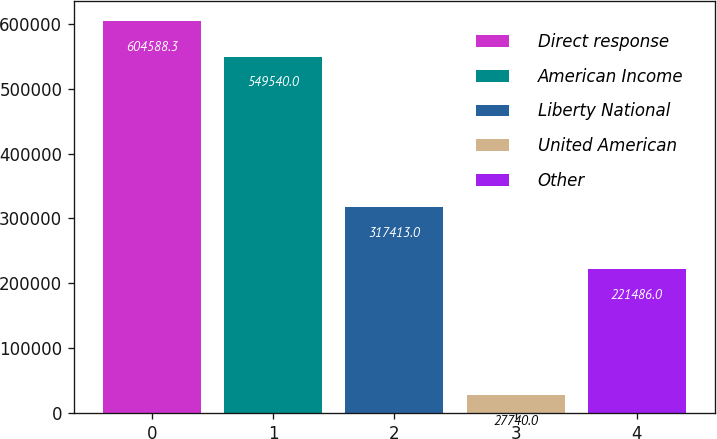<chart> <loc_0><loc_0><loc_500><loc_500><bar_chart><fcel>Direct response<fcel>American Income<fcel>Liberty National<fcel>United American<fcel>Other<nl><fcel>604588<fcel>549540<fcel>317413<fcel>27740<fcel>221486<nl></chart> 